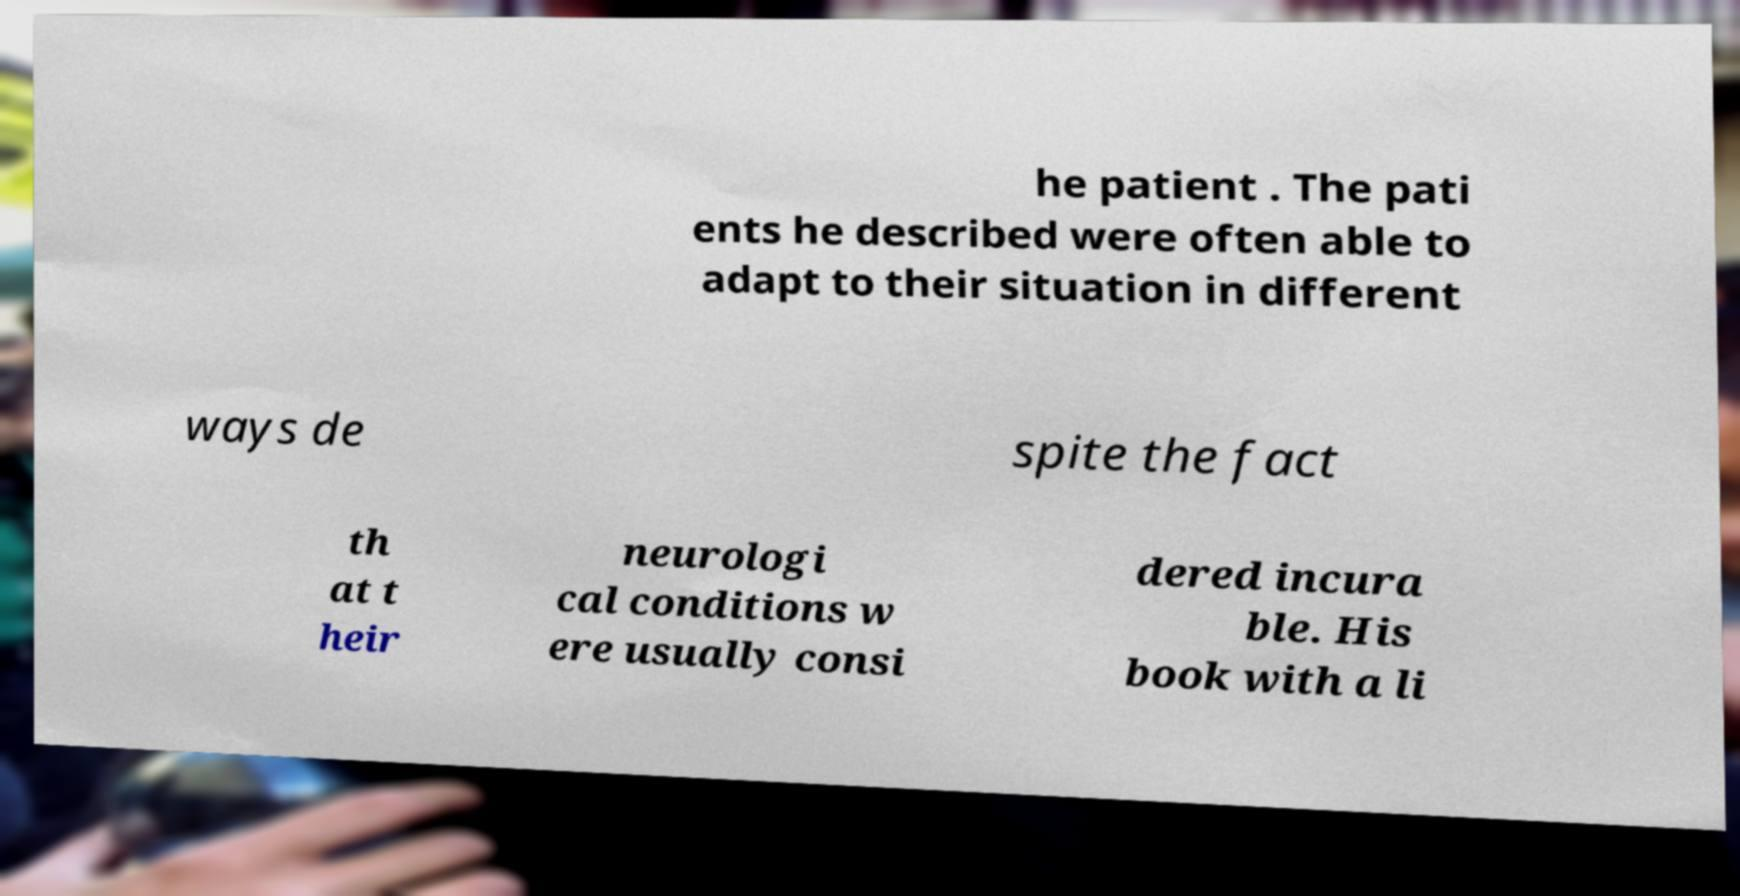I need the written content from this picture converted into text. Can you do that? he patient . The pati ents he described were often able to adapt to their situation in different ways de spite the fact th at t heir neurologi cal conditions w ere usually consi dered incura ble. His book with a li 